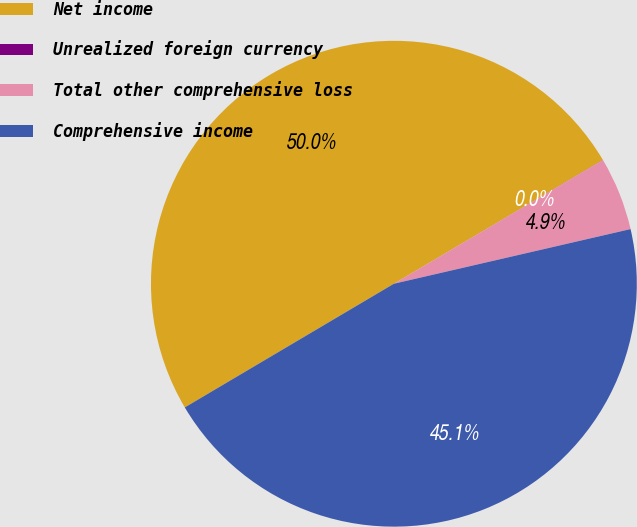<chart> <loc_0><loc_0><loc_500><loc_500><pie_chart><fcel>Net income<fcel>Unrealized foreign currency<fcel>Total other comprehensive loss<fcel>Comprehensive income<nl><fcel>49.99%<fcel>0.01%<fcel>4.89%<fcel>45.11%<nl></chart> 